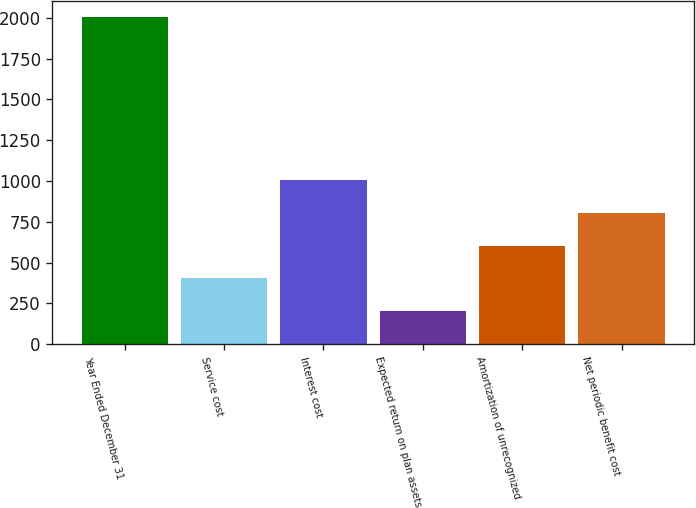Convert chart. <chart><loc_0><loc_0><loc_500><loc_500><bar_chart><fcel>Year Ended December 31<fcel>Service cost<fcel>Interest cost<fcel>Expected return on plan assets<fcel>Amortization of unrecognized<fcel>Net periodic benefit cost<nl><fcel>2004<fcel>402.48<fcel>1003.05<fcel>202.29<fcel>602.67<fcel>802.86<nl></chart> 